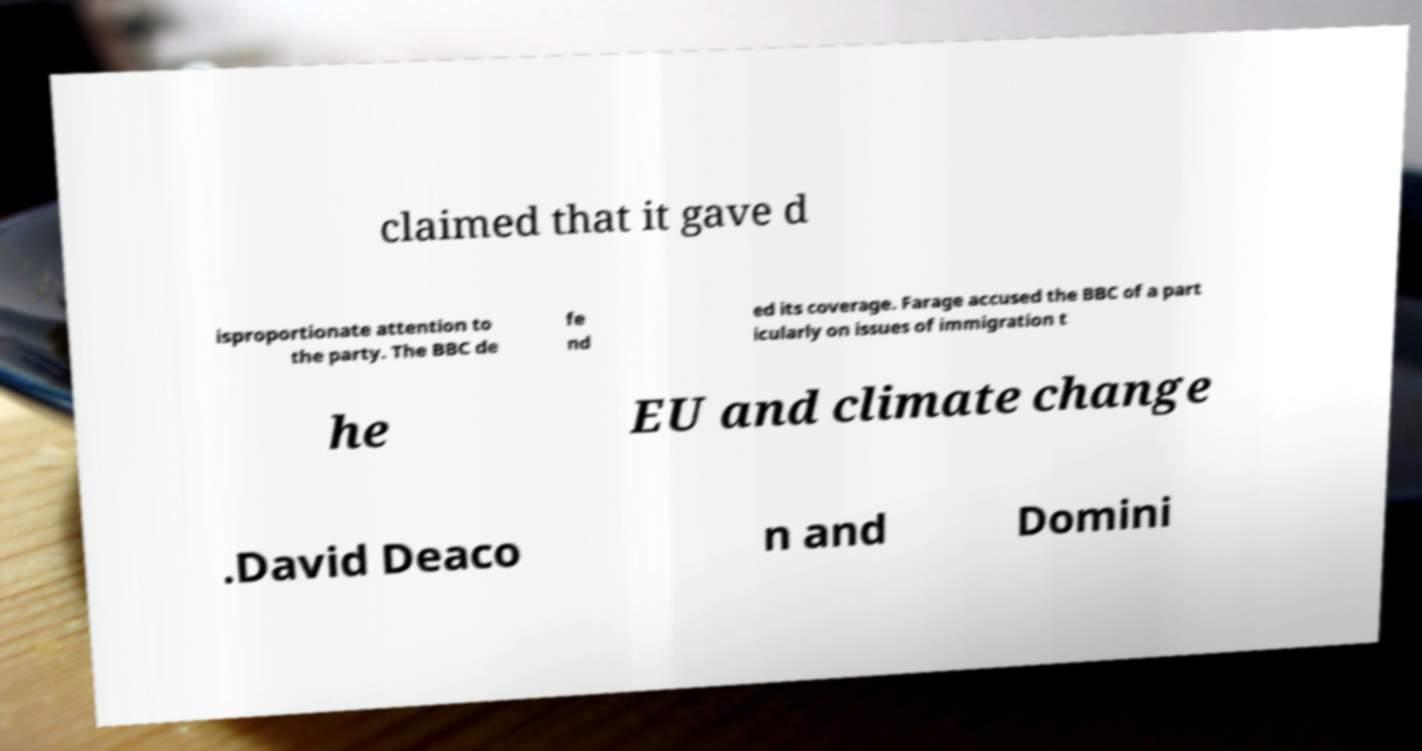For documentation purposes, I need the text within this image transcribed. Could you provide that? claimed that it gave d isproportionate attention to the party. The BBC de fe nd ed its coverage. Farage accused the BBC of a part icularly on issues of immigration t he EU and climate change .David Deaco n and Domini 